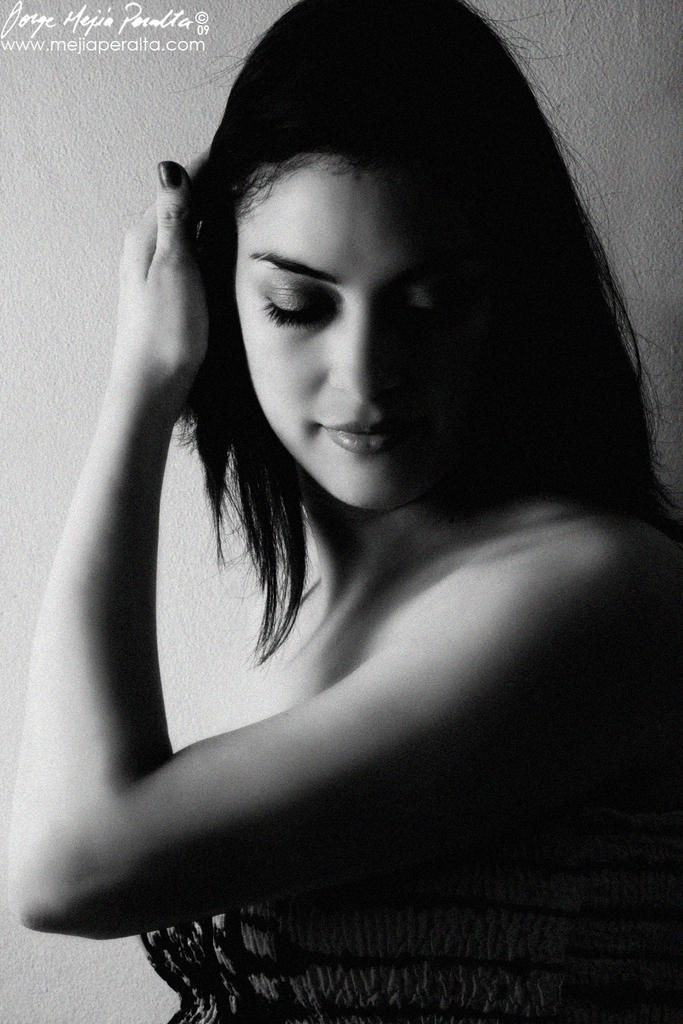What is the color scheme of the image? The image is black and white. Who or what is the main subject in the image? There are women in the center of the image. What can be seen in the background of the image? There is a wall in the background of the image. How many deer can be seen in the image? There are no deer present in the image. What type of grip do the women have on the wall in the image? There is no indication of the women interacting with the wall in the image, so it is not possible to determine their grip. 